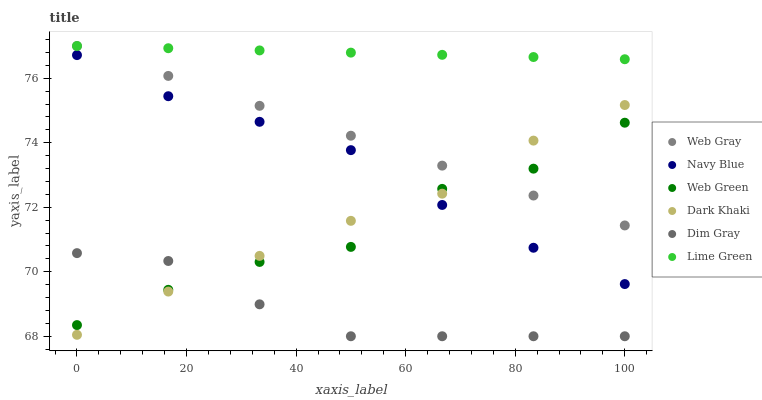Does Dim Gray have the minimum area under the curve?
Answer yes or no. Yes. Does Lime Green have the maximum area under the curve?
Answer yes or no. Yes. Does Navy Blue have the minimum area under the curve?
Answer yes or no. No. Does Navy Blue have the maximum area under the curve?
Answer yes or no. No. Is Lime Green the smoothest?
Answer yes or no. Yes. Is Web Green the roughest?
Answer yes or no. Yes. Is Navy Blue the smoothest?
Answer yes or no. No. Is Navy Blue the roughest?
Answer yes or no. No. Does Dim Gray have the lowest value?
Answer yes or no. Yes. Does Navy Blue have the lowest value?
Answer yes or no. No. Does Lime Green have the highest value?
Answer yes or no. Yes. Does Navy Blue have the highest value?
Answer yes or no. No. Is Dim Gray less than Lime Green?
Answer yes or no. Yes. Is Navy Blue greater than Dim Gray?
Answer yes or no. Yes. Does Navy Blue intersect Dark Khaki?
Answer yes or no. Yes. Is Navy Blue less than Dark Khaki?
Answer yes or no. No. Is Navy Blue greater than Dark Khaki?
Answer yes or no. No. Does Dim Gray intersect Lime Green?
Answer yes or no. No. 